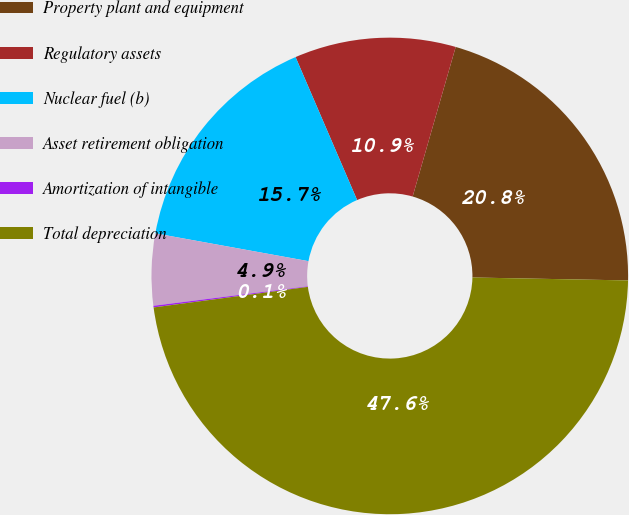<chart> <loc_0><loc_0><loc_500><loc_500><pie_chart><fcel>Property plant and equipment<fcel>Regulatory assets<fcel>Nuclear fuel (b)<fcel>Asset retirement obligation<fcel>Amortization of intangible<fcel>Total depreciation<nl><fcel>20.84%<fcel>10.93%<fcel>15.67%<fcel>4.86%<fcel>0.11%<fcel>47.59%<nl></chart> 